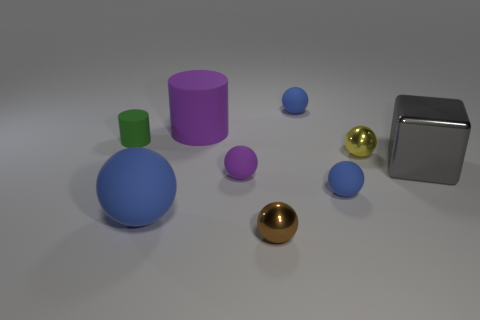Subtract all yellow cylinders. How many blue balls are left? 3 Subtract 1 spheres. How many spheres are left? 5 Subtract all purple balls. How many balls are left? 5 Subtract all purple rubber spheres. How many spheres are left? 5 Subtract all gray balls. Subtract all purple blocks. How many balls are left? 6 Add 1 green matte cylinders. How many objects exist? 10 Subtract all balls. How many objects are left? 3 Add 9 small green matte objects. How many small green matte objects are left? 10 Add 2 green cylinders. How many green cylinders exist? 3 Subtract 0 green balls. How many objects are left? 9 